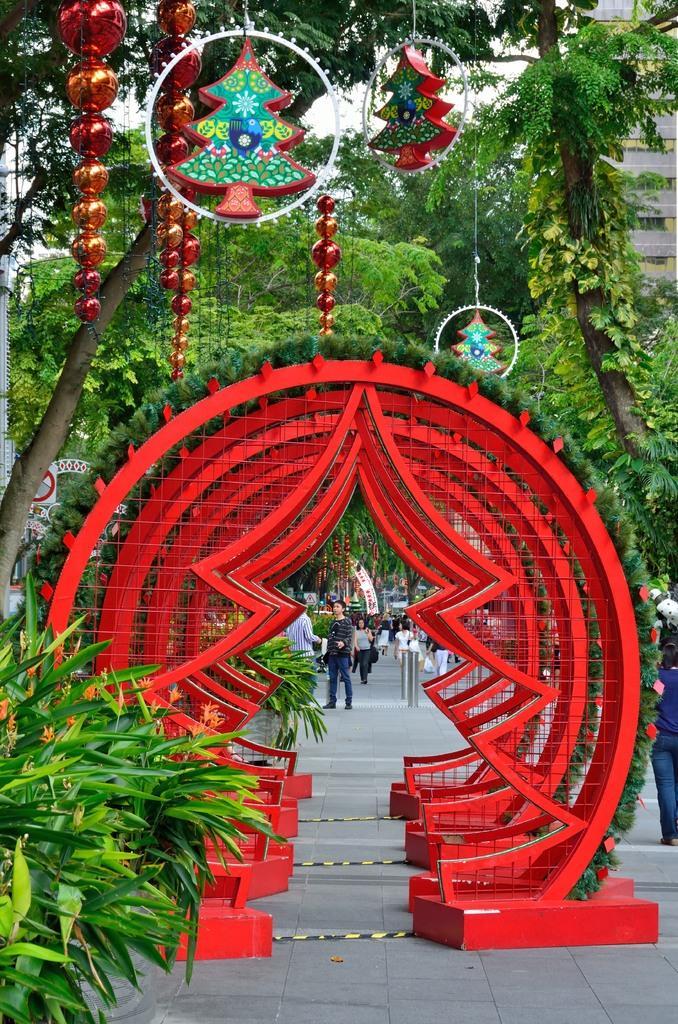Please provide a concise description of this image. On the left side, we see the shrubs and the trees. In the middle of the picture, we see the entrance, which is in the shape of the Christmas tree. It is in red color. Here, we see the people are walking on the pavement. On the right side, we see a woman is walking. In the background, we see the trees and a building. We see these trees are decorated with the decorative items. 